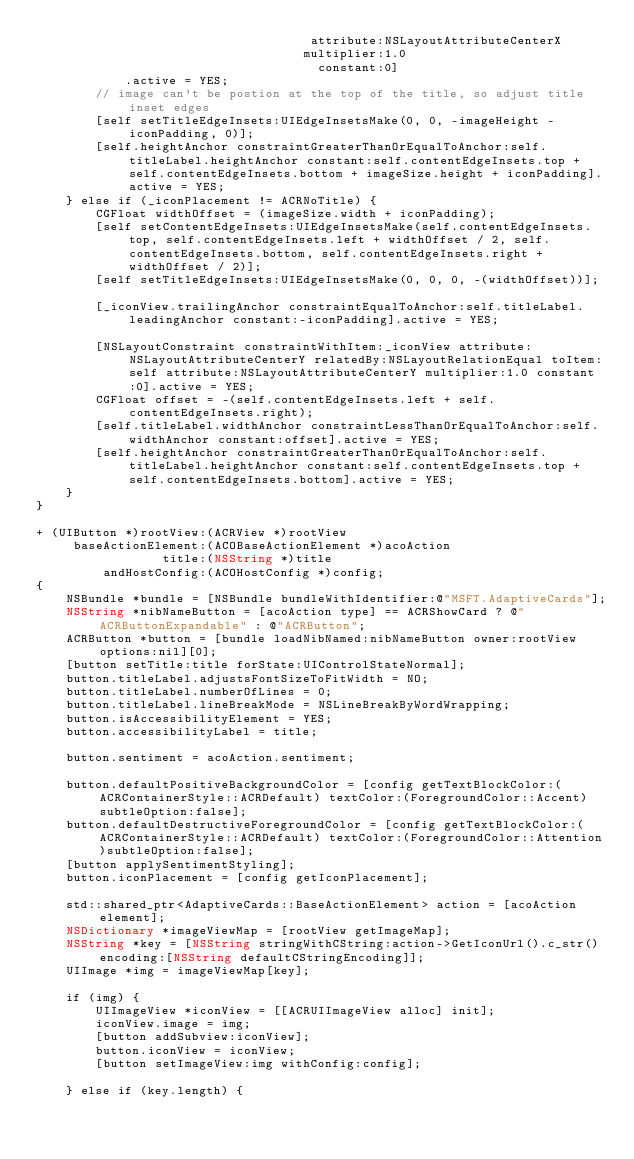<code> <loc_0><loc_0><loc_500><loc_500><_ObjectiveC_>                                     attribute:NSLayoutAttributeCenterX
                                    multiplier:1.0
                                      constant:0]
            .active = YES;
        // image can't be postion at the top of the title, so adjust title inset edges
        [self setTitleEdgeInsets:UIEdgeInsetsMake(0, 0, -imageHeight - iconPadding, 0)];
        [self.heightAnchor constraintGreaterThanOrEqualToAnchor:self.titleLabel.heightAnchor constant:self.contentEdgeInsets.top + self.contentEdgeInsets.bottom + imageSize.height + iconPadding].active = YES;
    } else if (_iconPlacement != ACRNoTitle) {
        CGFloat widthOffset = (imageSize.width + iconPadding);
        [self setContentEdgeInsets:UIEdgeInsetsMake(self.contentEdgeInsets.top, self.contentEdgeInsets.left + widthOffset / 2, self.contentEdgeInsets.bottom, self.contentEdgeInsets.right + widthOffset / 2)];
        [self setTitleEdgeInsets:UIEdgeInsetsMake(0, 0, 0, -(widthOffset))];

        [_iconView.trailingAnchor constraintEqualToAnchor:self.titleLabel.leadingAnchor constant:-iconPadding].active = YES;

        [NSLayoutConstraint constraintWithItem:_iconView attribute:NSLayoutAttributeCenterY relatedBy:NSLayoutRelationEqual toItem:self attribute:NSLayoutAttributeCenterY multiplier:1.0 constant:0].active = YES;
        CGFloat offset = -(self.contentEdgeInsets.left + self.contentEdgeInsets.right);
        [self.titleLabel.widthAnchor constraintLessThanOrEqualToAnchor:self.widthAnchor constant:offset].active = YES;
        [self.heightAnchor constraintGreaterThanOrEqualToAnchor:self.titleLabel.heightAnchor constant:self.contentEdgeInsets.top + self.contentEdgeInsets.bottom].active = YES;
    }
}

+ (UIButton *)rootView:(ACRView *)rootView
     baseActionElement:(ACOBaseActionElement *)acoAction
                 title:(NSString *)title
         andHostConfig:(ACOHostConfig *)config;
{
    NSBundle *bundle = [NSBundle bundleWithIdentifier:@"MSFT.AdaptiveCards"];
    NSString *nibNameButton = [acoAction type] == ACRShowCard ? @"ACRButtonExpandable" : @"ACRButton";
    ACRButton *button = [bundle loadNibNamed:nibNameButton owner:rootView options:nil][0];
    [button setTitle:title forState:UIControlStateNormal];
    button.titleLabel.adjustsFontSizeToFitWidth = NO;
    button.titleLabel.numberOfLines = 0;
    button.titleLabel.lineBreakMode = NSLineBreakByWordWrapping;
    button.isAccessibilityElement = YES;
    button.accessibilityLabel = title;

    button.sentiment = acoAction.sentiment;

    button.defaultPositiveBackgroundColor = [config getTextBlockColor:(ACRContainerStyle::ACRDefault) textColor:(ForegroundColor::Accent)subtleOption:false];
    button.defaultDestructiveForegroundColor = [config getTextBlockColor:(ACRContainerStyle::ACRDefault) textColor:(ForegroundColor::Attention)subtleOption:false];
    [button applySentimentStyling];
    button.iconPlacement = [config getIconPlacement];

    std::shared_ptr<AdaptiveCards::BaseActionElement> action = [acoAction element];
    NSDictionary *imageViewMap = [rootView getImageMap];
    NSString *key = [NSString stringWithCString:action->GetIconUrl().c_str() encoding:[NSString defaultCStringEncoding]];
    UIImage *img = imageViewMap[key];

    if (img) {
        UIImageView *iconView = [[ACRUIImageView alloc] init];
        iconView.image = img;
        [button addSubview:iconView];
        button.iconView = iconView;
        [button setImageView:img withConfig:config];

    } else if (key.length) {</code> 